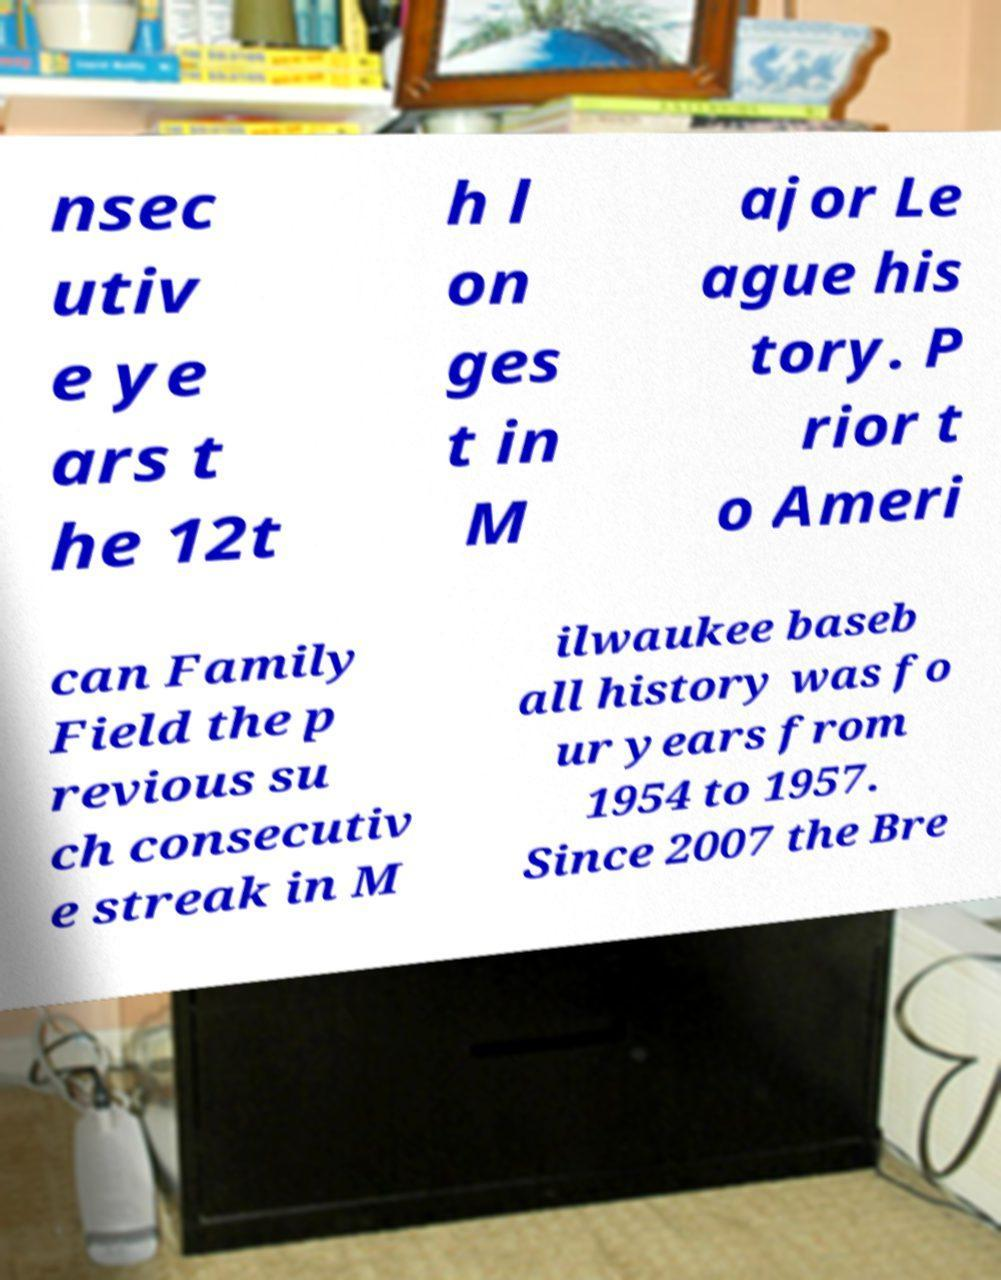Can you read and provide the text displayed in the image?This photo seems to have some interesting text. Can you extract and type it out for me? nsec utiv e ye ars t he 12t h l on ges t in M ajor Le ague his tory. P rior t o Ameri can Family Field the p revious su ch consecutiv e streak in M ilwaukee baseb all history was fo ur years from 1954 to 1957. Since 2007 the Bre 